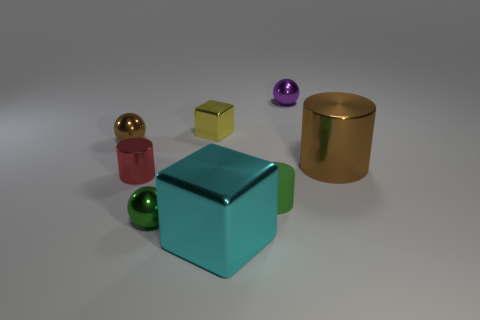What is the color of the shiny cylinder in front of the large object that is behind the large shiny object that is in front of the large cylinder?
Your response must be concise. Red. There is a object that is behind the small yellow metallic thing; is its color the same as the small shiny cylinder?
Provide a succinct answer. No. How many other objects are there of the same color as the tiny matte cylinder?
Make the answer very short. 1. How many things are purple spheres or large brown objects?
Your answer should be compact. 2. What number of objects are cylinders or blocks that are in front of the tiny red thing?
Your answer should be very brief. 4. Is the material of the brown cylinder the same as the tiny brown sphere?
Make the answer very short. Yes. How many other objects are there of the same material as the small cube?
Provide a succinct answer. 6. Is the number of tiny yellow rubber spheres greater than the number of large metallic cylinders?
Make the answer very short. No. Does the brown object left of the large brown cylinder have the same shape as the red thing?
Your answer should be very brief. No. Are there fewer gray rubber objects than red metal objects?
Your answer should be very brief. Yes. 